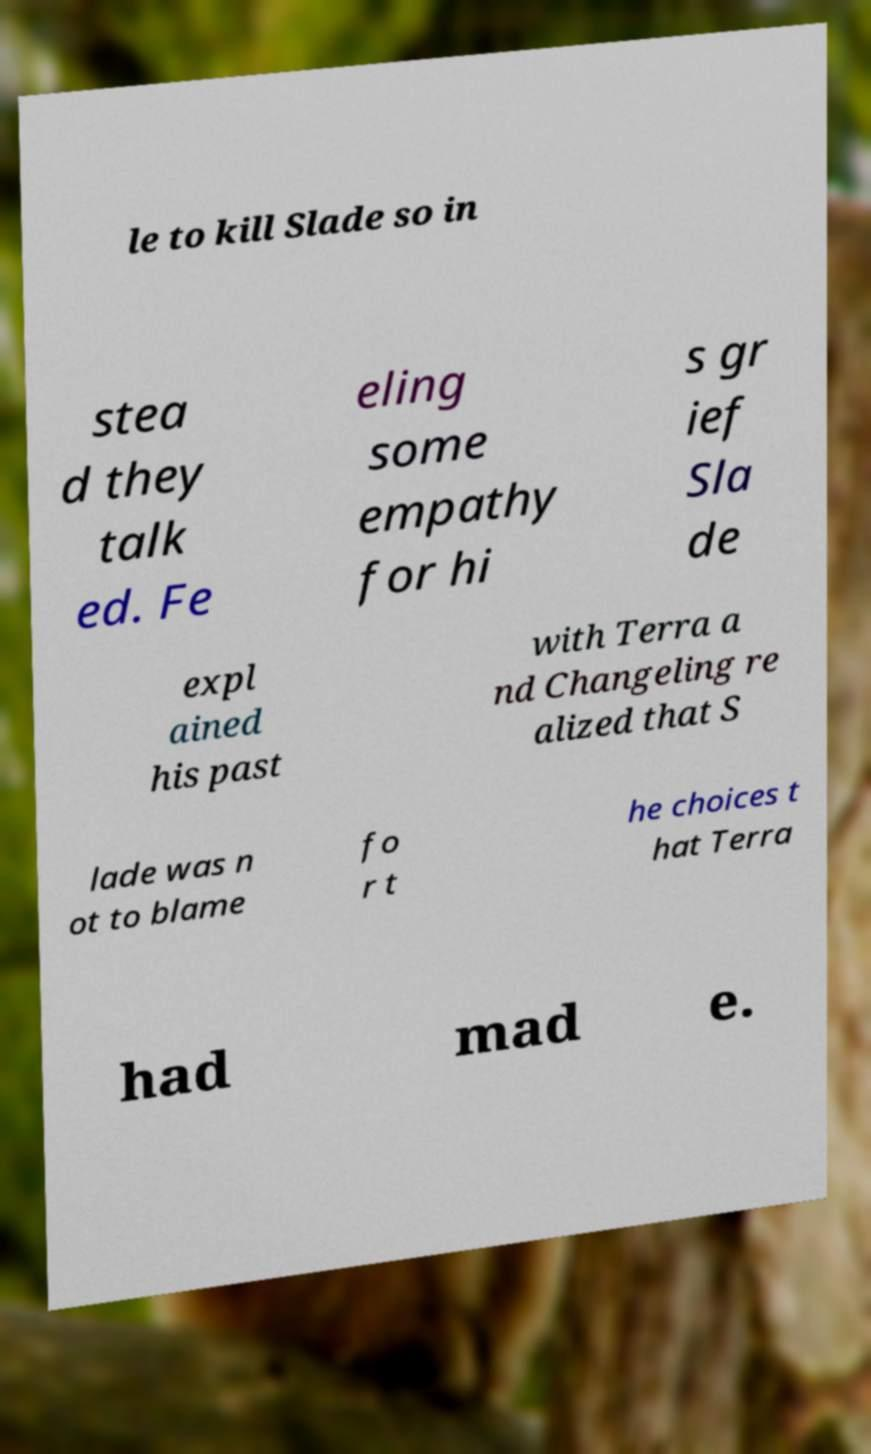For documentation purposes, I need the text within this image transcribed. Could you provide that? le to kill Slade so in stea d they talk ed. Fe eling some empathy for hi s gr ief Sla de expl ained his past with Terra a nd Changeling re alized that S lade was n ot to blame fo r t he choices t hat Terra had mad e. 